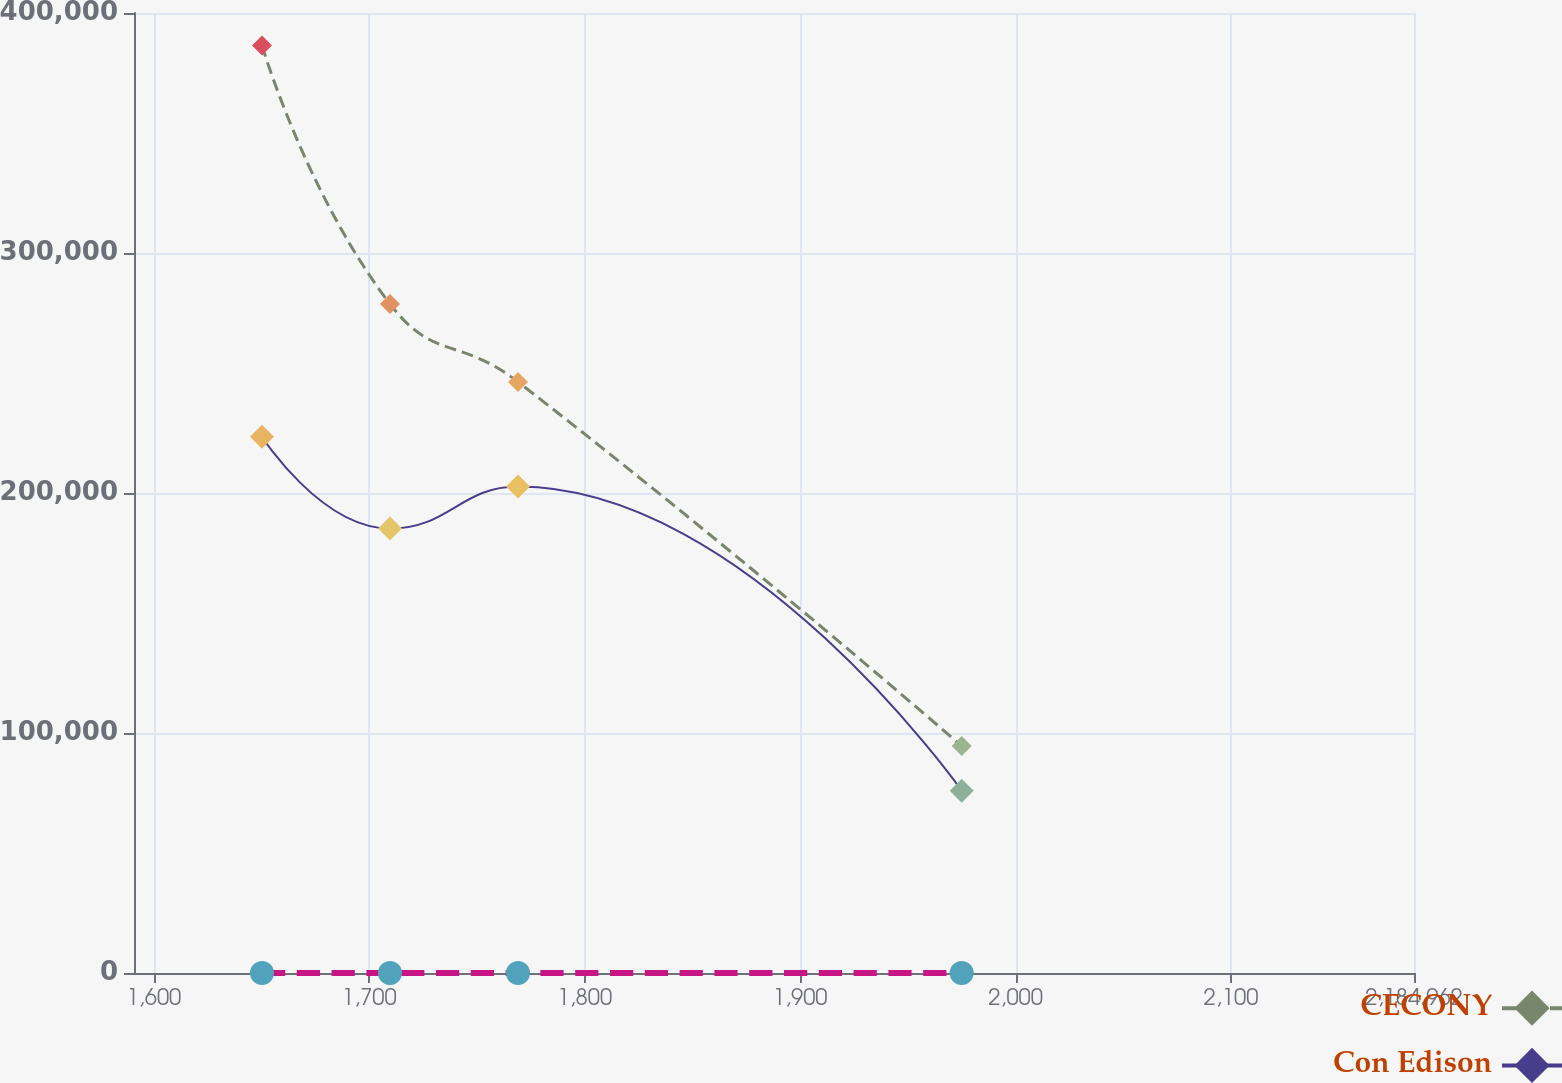Convert chart. <chart><loc_0><loc_0><loc_500><loc_500><line_chart><ecel><fcel>Unnamed: 1<fcel>CECONY<fcel>Con Edison<nl><fcel>1650.2<fcel>3.5<fcel>386461<fcel>223443<nl><fcel>1709.62<fcel>2.99<fcel>278744<fcel>185178<nl><fcel>1769.04<fcel>2.02<fcel>246283<fcel>202712<nl><fcel>1974.99<fcel>0.89<fcel>94540.2<fcel>75976.5<nl><fcel>2244.38<fcel>1.15<fcel>61855.8<fcel>48097.8<nl></chart> 